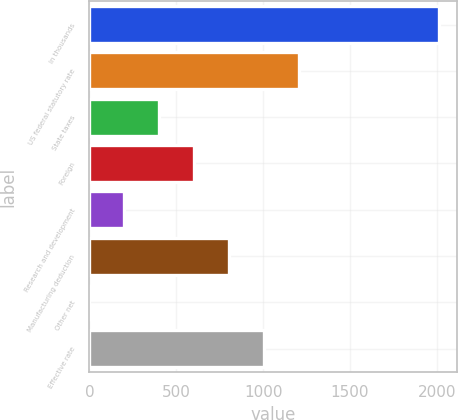Convert chart to OTSL. <chart><loc_0><loc_0><loc_500><loc_500><bar_chart><fcel>In thousands<fcel>US federal statutory rate<fcel>State taxes<fcel>Foreign<fcel>Research and development<fcel>Manufacturing deduction<fcel>Other net<fcel>Effective rate<nl><fcel>2015<fcel>1209.04<fcel>403.08<fcel>604.57<fcel>201.59<fcel>806.06<fcel>0.1<fcel>1007.55<nl></chart> 